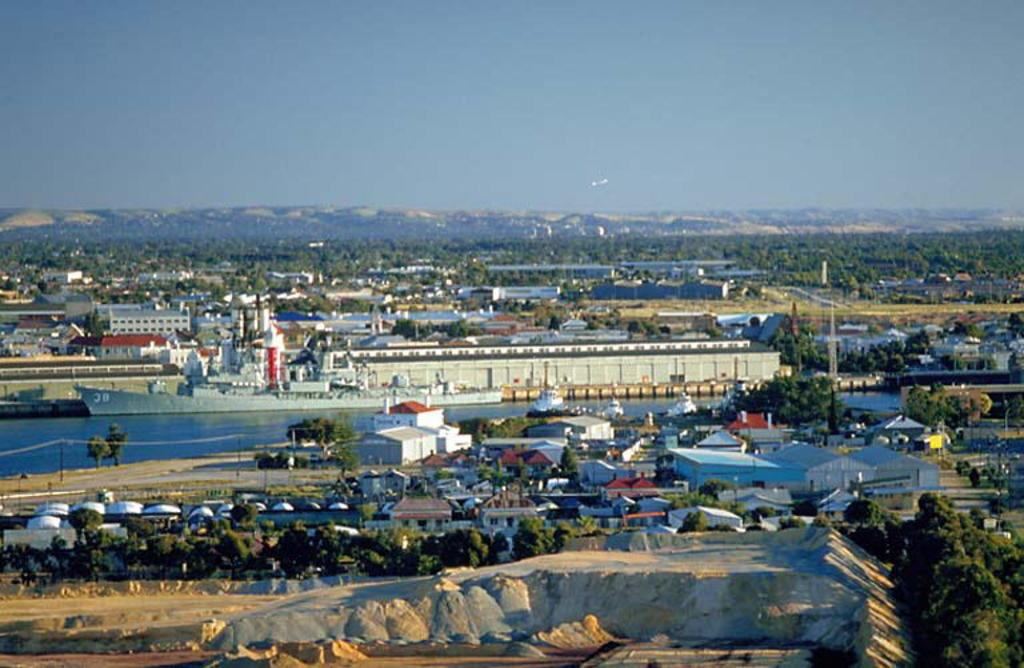What type of structures can be seen in the image? There are buildings and houses in the image. What natural elements are present in the image? There are trees, plants, mountains, and hills in the image. Can you see a snail crawling on the chessboard in the image? There is no chessboard or snail present in the image. 